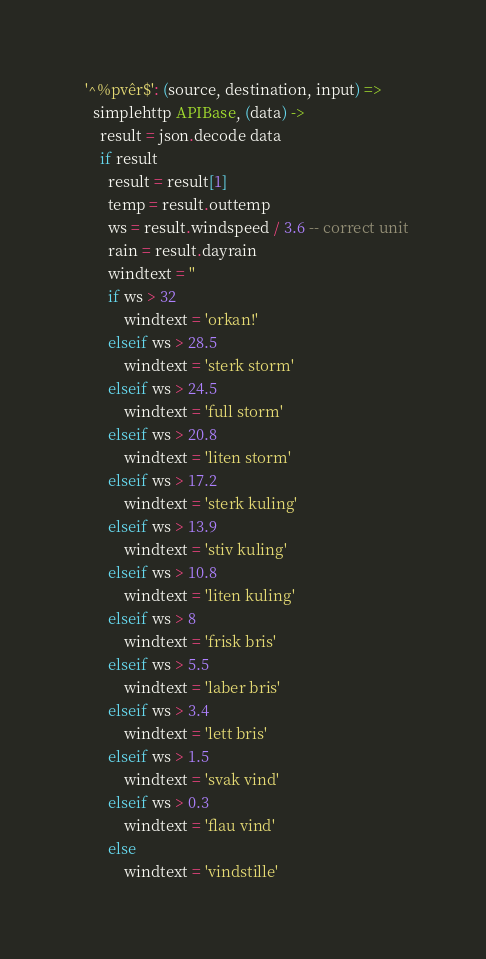<code> <loc_0><loc_0><loc_500><loc_500><_MoonScript_>  '^%pvêr$': (source, destination, input) =>
    simplehttp APIBase, (data) ->
      result = json.decode data 
      if result
        result = result[1]
        temp = result.outtemp
        ws = result.windspeed / 3.6 -- correct unit
        rain = result.dayrain
        windtext = ''
        if ws > 32
            windtext = 'orkan!'
        elseif ws > 28.5 
            windtext = 'sterk storm'
        elseif ws > 24.5 
            windtext = 'full storm'
        elseif ws > 20.8 
            windtext = 'liten storm'
        elseif ws > 17.2 
            windtext = 'sterk kuling'
        elseif ws > 13.9 
            windtext = 'stiv kuling'
        elseif ws > 10.8 
            windtext = 'liten kuling'
        elseif ws > 8 
            windtext = 'frisk bris'
        elseif ws > 5.5 
            windtext = 'laber bris'
        elseif ws > 3.4 
            windtext = 'lett bris'
        elseif ws > 1.5 
            windtext = 'svak vind'
        elseif ws > 0.3 
            windtext = 'flau vind'
        else 
            windtext = 'vindstille'

</code> 